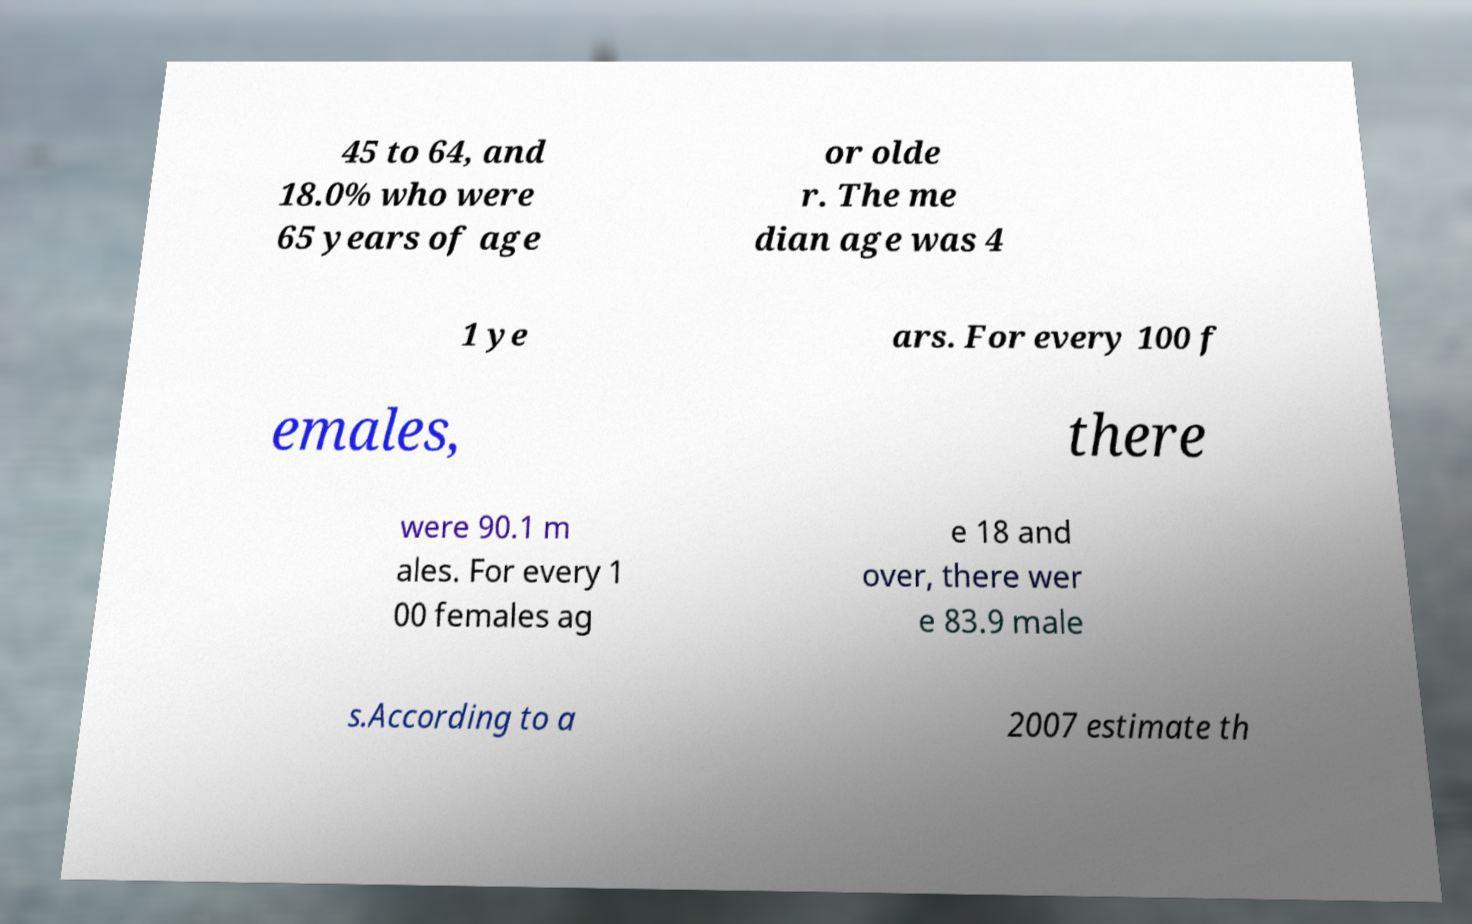I need the written content from this picture converted into text. Can you do that? 45 to 64, and 18.0% who were 65 years of age or olde r. The me dian age was 4 1 ye ars. For every 100 f emales, there were 90.1 m ales. For every 1 00 females ag e 18 and over, there wer e 83.9 male s.According to a 2007 estimate th 